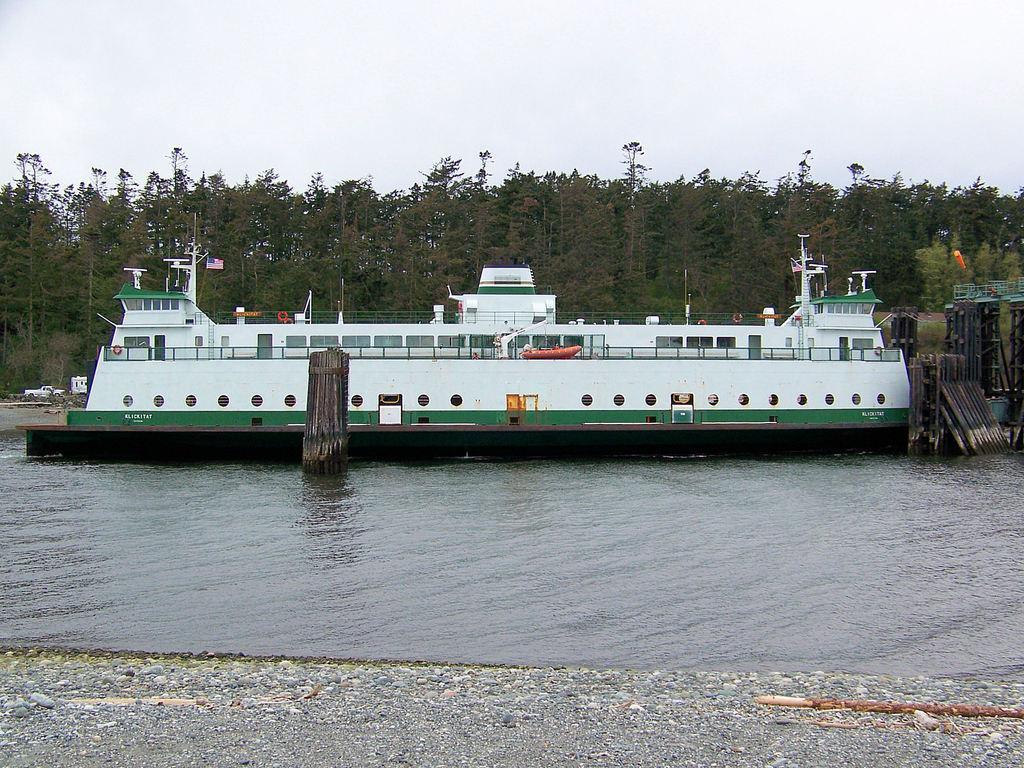Could you give a brief overview of what you see in this image? in this image in the front there is water and there is a ship on the water. In the background there are trees and on the right side there are metal objects and in the background there are objects which are white in colour and the sky is cloudy. 